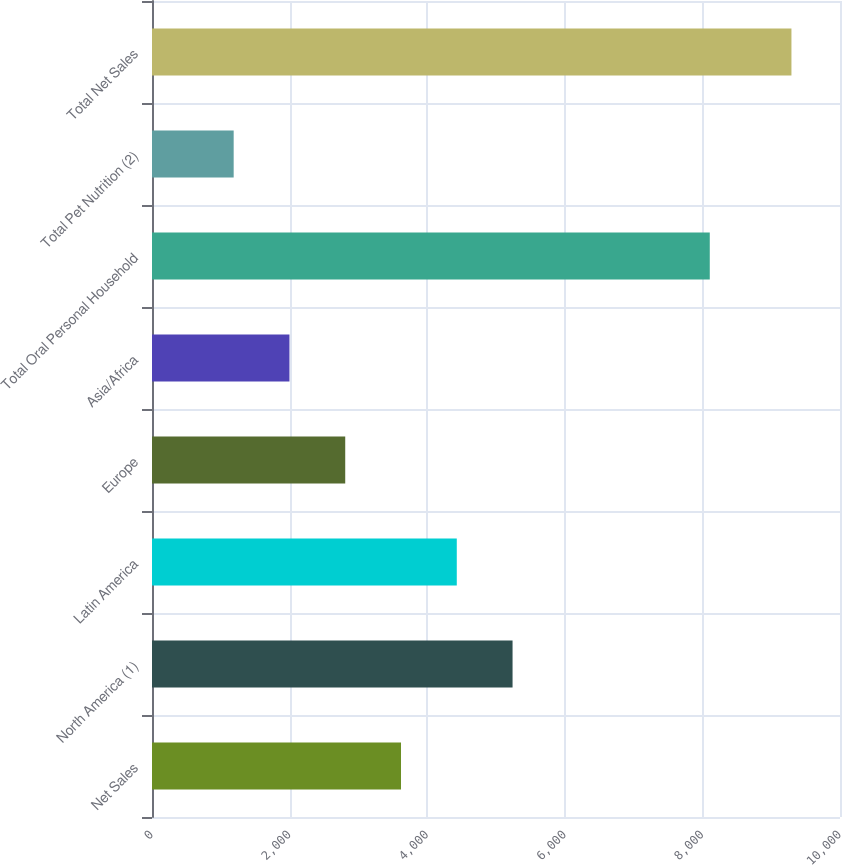Convert chart to OTSL. <chart><loc_0><loc_0><loc_500><loc_500><bar_chart><fcel>Net Sales<fcel>North America (1)<fcel>Latin America<fcel>Europe<fcel>Asia/Africa<fcel>Total Oral Personal Household<fcel>Total Pet Nutrition (2)<fcel>Total Net Sales<nl><fcel>3619.26<fcel>5240.7<fcel>4429.98<fcel>2808.54<fcel>1997.82<fcel>8107.2<fcel>1187.1<fcel>9294.3<nl></chart> 